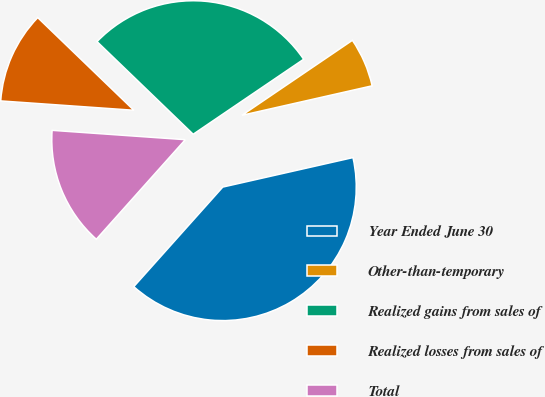Convert chart to OTSL. <chart><loc_0><loc_0><loc_500><loc_500><pie_chart><fcel>Year Ended June 30<fcel>Other-than-temporary<fcel>Realized gains from sales of<fcel>Realized losses from sales of<fcel>Total<nl><fcel>40.15%<fcel>5.95%<fcel>28.3%<fcel>11.09%<fcel>14.51%<nl></chart> 